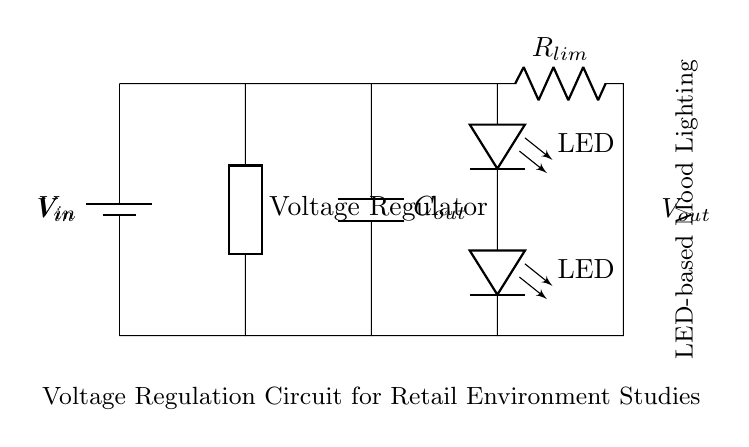What type of voltage regulator is used in this circuit? The circuit shows a generic voltage regulator depicted by the label "Voltage Regulator." This indicates that the circuit is using a standard voltage regulation component, not a specific type like linear or switching.
Answer: Voltage regulator What is the function of the output capacitor? The output capacitor, labeled Cout, stabilizes the output voltage by reducing ripple and providing a reservoir of charge. It smooths out voltage fluctuations caused by the load.
Answer: Stabilization How many LEDs are connected in this circuit? There are two LEDs connected in series, inferred from the two labeled LED components in the circuit diagram. Each LED is represented distinctly, indicating their separate function in the circuit.
Answer: Two What component limits the current to the LEDs? The current-limiting resistor, denoted as Rlim, controls the electrical current flowing through the LEDs to prevent them from burning out due to excessive current. This resistor's value is essential to ensure the LEDs operate within safe limits.
Answer: Resistor What is the role of the battery in this circuit? The battery, labeled Vin, serves as the power source, providing the necessary input voltage for the entire circuit. This battery is crucial as it defines the operating voltage for both the voltage regulator and the connected LEDs.
Answer: Power source 